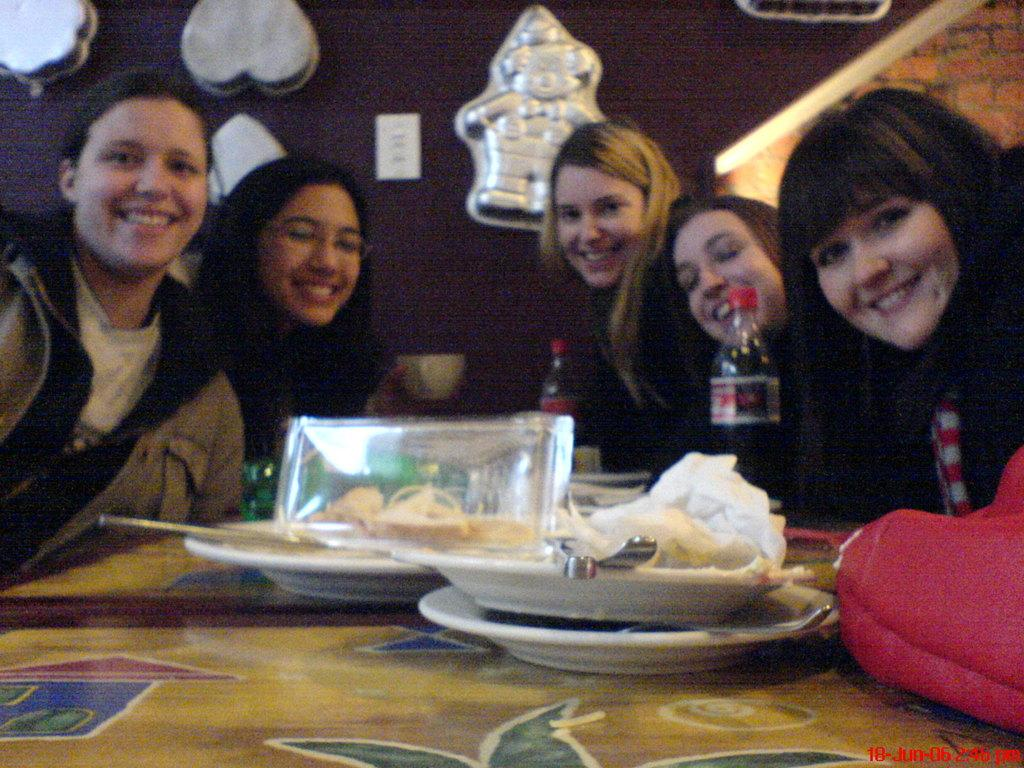What are the persons in the image doing? The persons in the image are sitting on chairs. What is in front of the persons? There is a table in front of the persons. What can be seen on the table? There are plates, spoons, and a bottle on the table. What is on the wall in the image? There are moulds on the wall. Can you tell me how many toothbrushes are on the table in the image? There are no toothbrushes present on the table in the image. What type of airport is visible in the image? There is no airport visible in the image. 